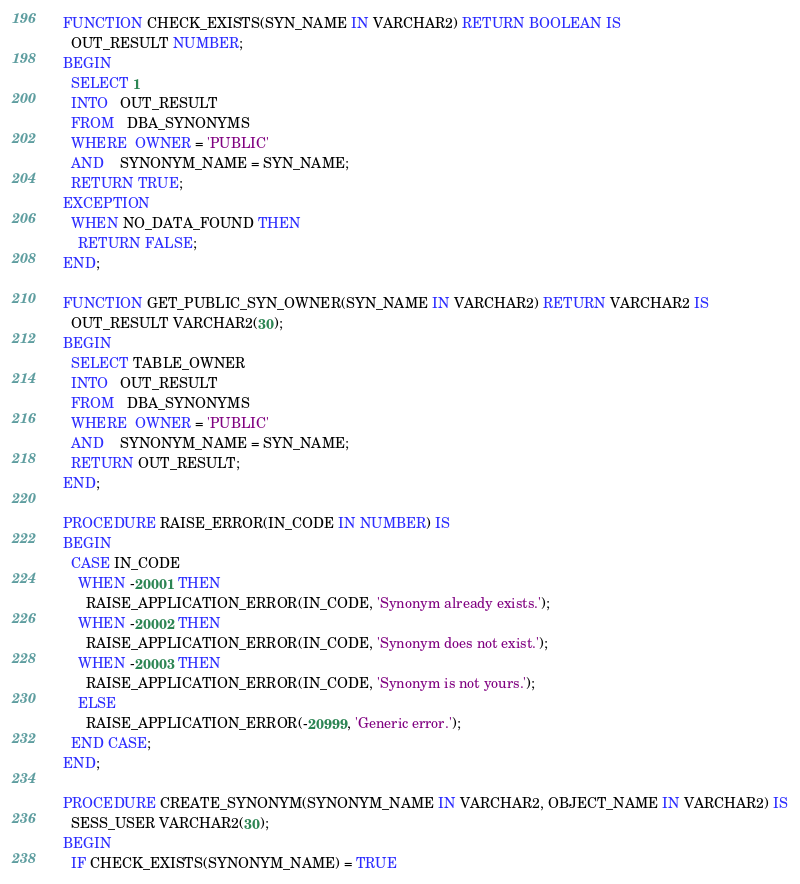<code> <loc_0><loc_0><loc_500><loc_500><_SQL_>  FUNCTION CHECK_EXISTS(SYN_NAME IN VARCHAR2) RETURN BOOLEAN IS
    OUT_RESULT NUMBER;
  BEGIN
    SELECT 1
    INTO   OUT_RESULT
    FROM   DBA_SYNONYMS
    WHERE  OWNER = 'PUBLIC'
    AND    SYNONYM_NAME = SYN_NAME;
    RETURN TRUE;
  EXCEPTION
    WHEN NO_DATA_FOUND THEN
      RETURN FALSE;
  END;

  FUNCTION GET_PUBLIC_SYN_OWNER(SYN_NAME IN VARCHAR2) RETURN VARCHAR2 IS
    OUT_RESULT VARCHAR2(30);
  BEGIN
    SELECT TABLE_OWNER
    INTO   OUT_RESULT
    FROM   DBA_SYNONYMS
    WHERE  OWNER = 'PUBLIC'
    AND    SYNONYM_NAME = SYN_NAME;
    RETURN OUT_RESULT;
  END;

  PROCEDURE RAISE_ERROR(IN_CODE IN NUMBER) IS
  BEGIN
    CASE IN_CODE
      WHEN -20001 THEN
        RAISE_APPLICATION_ERROR(IN_CODE, 'Synonym already exists.');
      WHEN -20002 THEN
        RAISE_APPLICATION_ERROR(IN_CODE, 'Synonym does not exist.');
      WHEN -20003 THEN
        RAISE_APPLICATION_ERROR(IN_CODE, 'Synonym is not yours.');
      ELSE
        RAISE_APPLICATION_ERROR(-20999, 'Generic error.');
    END CASE;
  END;

  PROCEDURE CREATE_SYNONYM(SYNONYM_NAME IN VARCHAR2, OBJECT_NAME IN VARCHAR2) IS
    SESS_USER VARCHAR2(30);
  BEGIN
    IF CHECK_EXISTS(SYNONYM_NAME) = TRUE</code> 